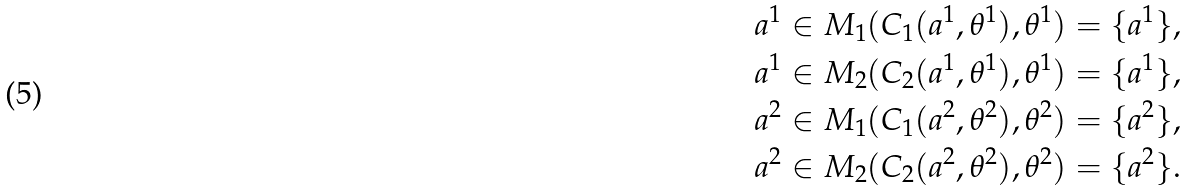Convert formula to latex. <formula><loc_0><loc_0><loc_500><loc_500>& a ^ { 1 } \in M _ { 1 } ( C _ { 1 } ( a ^ { 1 } , \theta ^ { 1 } ) , \theta ^ { 1 } ) = \{ a ^ { 1 } \} , \\ & a ^ { 1 } \in M _ { 2 } ( C _ { 2 } ( a ^ { 1 } , \theta ^ { 1 } ) , \theta ^ { 1 } ) = \{ a ^ { 1 } \} , \\ & a ^ { 2 } \in M _ { 1 } ( C _ { 1 } ( a ^ { 2 } , \theta ^ { 2 } ) , \theta ^ { 2 } ) = \{ a ^ { 2 } \} , \\ & a ^ { 2 } \in M _ { 2 } ( C _ { 2 } ( a ^ { 2 } , \theta ^ { 2 } ) , \theta ^ { 2 } ) = \{ a ^ { 2 } \} .</formula> 